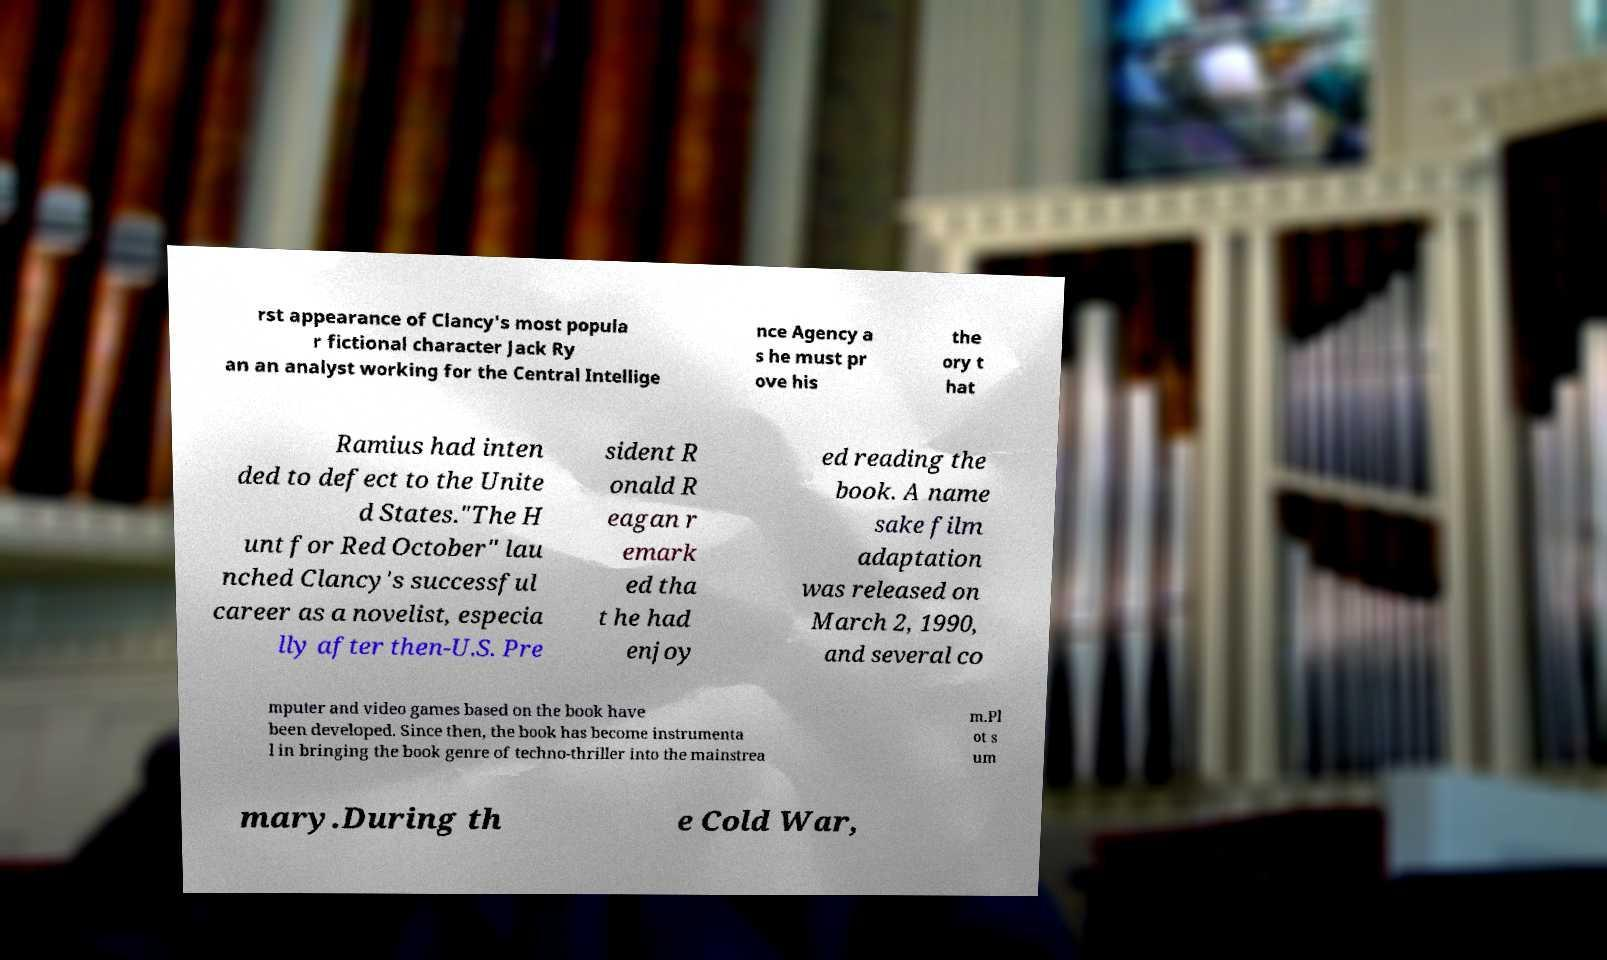Can you read and provide the text displayed in the image?This photo seems to have some interesting text. Can you extract and type it out for me? rst appearance of Clancy's most popula r fictional character Jack Ry an an analyst working for the Central Intellige nce Agency a s he must pr ove his the ory t hat Ramius had inten ded to defect to the Unite d States."The H unt for Red October" lau nched Clancy's successful career as a novelist, especia lly after then-U.S. Pre sident R onald R eagan r emark ed tha t he had enjoy ed reading the book. A name sake film adaptation was released on March 2, 1990, and several co mputer and video games based on the book have been developed. Since then, the book has become instrumenta l in bringing the book genre of techno-thriller into the mainstrea m.Pl ot s um mary.During th e Cold War, 